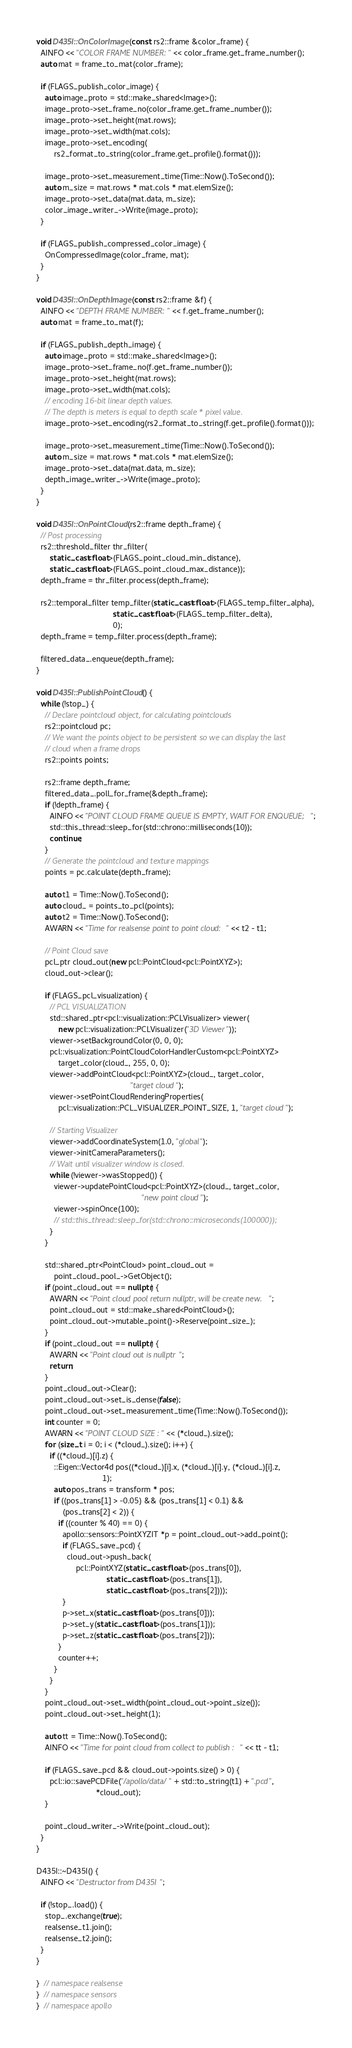Convert code to text. <code><loc_0><loc_0><loc_500><loc_500><_C++_>void D435I::OnColorImage(const rs2::frame &color_frame) {
  AINFO << "COLOR FRAME NUMBER:" << color_frame.get_frame_number();
  auto mat = frame_to_mat(color_frame);

  if (FLAGS_publish_color_image) {
    auto image_proto = std::make_shared<Image>();
    image_proto->set_frame_no(color_frame.get_frame_number());
    image_proto->set_height(mat.rows);
    image_proto->set_width(mat.cols);
    image_proto->set_encoding(
        rs2_format_to_string(color_frame.get_profile().format()));

    image_proto->set_measurement_time(Time::Now().ToSecond());
    auto m_size = mat.rows * mat.cols * mat.elemSize();
    image_proto->set_data(mat.data, m_size);
    color_image_writer_->Write(image_proto);
  }

  if (FLAGS_publish_compressed_color_image) {
    OnCompressedImage(color_frame, mat);
  }
}

void D435I::OnDepthImage(const rs2::frame &f) {
  AINFO << "DEPTH FRAME NUMBER:" << f.get_frame_number();
  auto mat = frame_to_mat(f);

  if (FLAGS_publish_depth_image) {
    auto image_proto = std::make_shared<Image>();
    image_proto->set_frame_no(f.get_frame_number());
    image_proto->set_height(mat.rows);
    image_proto->set_width(mat.cols);
    // encoding 16-bit linear depth values.
    // The depth is meters is equal to depth scale * pixel value.
    image_proto->set_encoding(rs2_format_to_string(f.get_profile().format()));

    image_proto->set_measurement_time(Time::Now().ToSecond());
    auto m_size = mat.rows * mat.cols * mat.elemSize();
    image_proto->set_data(mat.data, m_size);
    depth_image_writer_->Write(image_proto);
  }
}

void D435I::OnPointCloud(rs2::frame depth_frame) {
  // Post processing
  rs2::threshold_filter thr_filter(
      static_cast<float>(FLAGS_point_cloud_min_distance),
      static_cast<float>(FLAGS_point_cloud_max_distance));
  depth_frame = thr_filter.process(depth_frame);

  rs2::temporal_filter temp_filter(static_cast<float>(FLAGS_temp_filter_alpha),
                                   static_cast<float>(FLAGS_temp_filter_delta),
                                   0);
  depth_frame = temp_filter.process(depth_frame);

  filtered_data_.enqueue(depth_frame);
}

void D435I::PublishPointCloud() {
  while (!stop_) {
    // Declare pointcloud object, for calculating pointclouds
    rs2::pointcloud pc;
    // We want the points object to be persistent so we can display the last
    // cloud when a frame drops
    rs2::points points;

    rs2::frame depth_frame;
    filtered_data_.poll_for_frame(&depth_frame);
    if (!depth_frame) {
      AINFO << "POINT CLOUD FRAME QUEUE IS EMPTY, WAIT FOR ENQUEUE;";
      std::this_thread::sleep_for(std::chrono::milliseconds(10));
      continue;
    }
    // Generate the pointcloud and texture mappings
    points = pc.calculate(depth_frame);

    auto t1 = Time::Now().ToSecond();
    auto cloud_ = points_to_pcl(points);
    auto t2 = Time::Now().ToSecond();
    AWARN << "Time for realsense point to point cloud:" << t2 - t1;

    // Point Cloud save
    pcl_ptr cloud_out(new pcl::PointCloud<pcl::PointXYZ>);
    cloud_out->clear();

    if (FLAGS_pcl_visualization) {
      // PCL VISUALIZATION
      std::shared_ptr<pcl::visualization::PCLVisualizer> viewer(
          new pcl::visualization::PCLVisualizer("3D Viewer"));
      viewer->setBackgroundColor(0, 0, 0);
      pcl::visualization::PointCloudColorHandlerCustom<pcl::PointXYZ>
          target_color(cloud_, 255, 0, 0);
      viewer->addPointCloud<pcl::PointXYZ>(cloud_, target_color,
                                           "target cloud");
      viewer->setPointCloudRenderingProperties(
          pcl::visualization::PCL_VISUALIZER_POINT_SIZE, 1, "target cloud");

      // Starting Visualizer
      viewer->addCoordinateSystem(1.0, "global");
      viewer->initCameraParameters();
      // Wait until visualizer window is closed.
      while (!viewer->wasStopped()) {
        viewer->updatePointCloud<pcl::PointXYZ>(cloud_, target_color,
                                                "new point cloud");
        viewer->spinOnce(100);
        // std::this_thread::sleep_for(std::chrono::microseconds(100000));
      }
    }

    std::shared_ptr<PointCloud> point_cloud_out =
        point_cloud_pool_->GetObject();
    if (point_cloud_out == nullptr) {
      AWARN << "Point cloud pool return nullptr, will be create new.";
      point_cloud_out = std::make_shared<PointCloud>();
      point_cloud_out->mutable_point()->Reserve(point_size_);
    }
    if (point_cloud_out == nullptr) {
      AWARN << "Point cloud out is nullptr";
      return;
    }
    point_cloud_out->Clear();
    point_cloud_out->set_is_dense(false);
    point_cloud_out->set_measurement_time(Time::Now().ToSecond());
    int counter = 0;
    AWARN << "POINT CLOUD SIZE :" << (*cloud_).size();
    for (size_t i = 0; i < (*cloud_).size(); i++) {
      if ((*cloud_)[i].z) {
        ::Eigen::Vector4d pos((*cloud_)[i].x, (*cloud_)[i].y, (*cloud_)[i].z,
                              1);
        auto pos_trans = transform * pos;
        if ((pos_trans[1] > -0.05) && (pos_trans[1] < 0.1) &&
            (pos_trans[2] < 2)) {
          if ((counter % 40) == 0) {
            apollo::sensors::PointXYZIT *p = point_cloud_out->add_point();
            if (FLAGS_save_pcd) {
              cloud_out->push_back(
                  pcl::PointXYZ(static_cast<float>(pos_trans[0]),
                                static_cast<float>(pos_trans[1]),
                                static_cast<float>(pos_trans[2])));
            }
            p->set_x(static_cast<float>(pos_trans[0]));
            p->set_y(static_cast<float>(pos_trans[1]));
            p->set_z(static_cast<float>(pos_trans[2]));
          }
          counter++;
        }
      }
    }
    point_cloud_out->set_width(point_cloud_out->point_size());
    point_cloud_out->set_height(1);

    auto tt = Time::Now().ToSecond();
    AINFO << "Time for point cloud from collect to publish :" << tt - t1;

    if (FLAGS_save_pcd && cloud_out->points.size() > 0) {
      pcl::io::savePCDFile("/apollo/data/" + std::to_string(t1) + ".pcd",
                           *cloud_out);
    }

    point_cloud_writer_->Write(point_cloud_out);
  }
}

D435I::~D435I() {
  AINFO << "Destructor from D435I";

  if (!stop_.load()) {
    stop_.exchange(true);
    realsense_t1.join();
    realsense_t2.join();
  }
}

}  // namespace realsense
}  // namespace sensors
}  // namespace apollo
</code> 